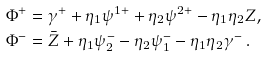<formula> <loc_0><loc_0><loc_500><loc_500>\Phi ^ { + } & = \gamma ^ { + } + \eta _ { 1 } \psi ^ { 1 + } + \eta _ { 2 } \psi ^ { 2 + } - \eta _ { 1 } \eta _ { 2 } Z , \\ \Phi ^ { - } & = \bar { Z } + \eta _ { 1 } \psi ^ { - } _ { 2 } - \eta _ { 2 } \psi ^ { - } _ { 1 } - \eta _ { 1 } \eta _ { 2 } \gamma ^ { - } \, .</formula> 